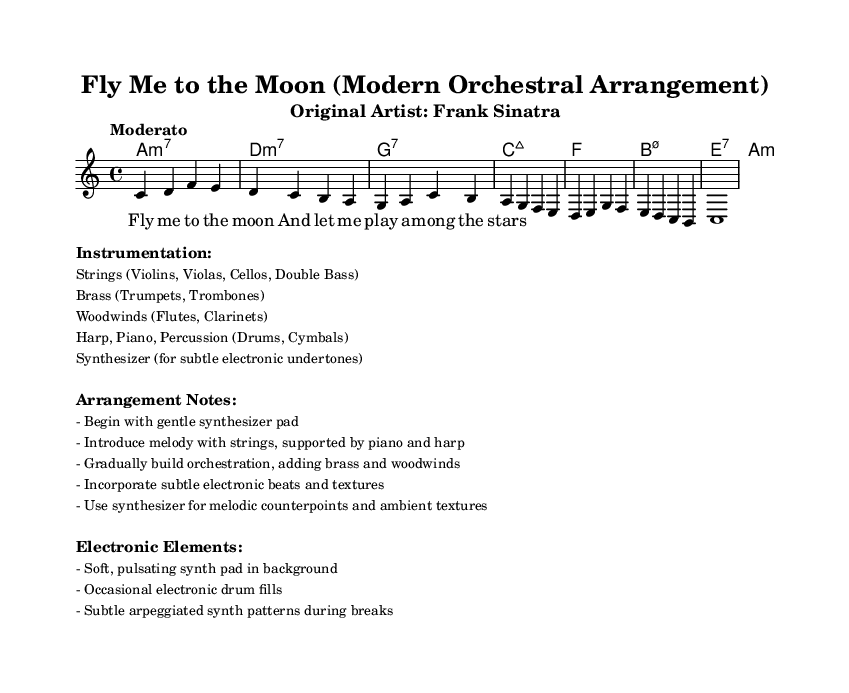What is the key signature of this music? The key signature is C major, which has no sharps or flats.
Answer: C major What is the time signature of this piece? The time signature is indicated at the beginning of the score, showing there are four beats per measure.
Answer: 4/4 What is the tempo marking for the arrangement? The tempo marking indicates it should be played at a moderate pace, as specified in the score at the beginning.
Answer: Moderato How many instruments are listed in the instrumentation? The instrumentation section explicitly lists six categories of instruments involved in the arrangement.
Answer: Six What is the first electronic element mentioned in the arrangement notes? The arrangement notes specify that the piece should begin with a gentle synthesizer pad, highlighting the first electronic element used.
Answer: Synthesizer pad What type of chord progression is used in this arrangement? The chord progression consists of various seventh chords that provide a lush harmonic foundation throughout the piece.
Answer: Seventh chords What is the melodic instrument highlighted in this arrangement? The arrangement notes indicate that the melody is introduced by strings, making them the primary melodic instrument in this version of the piece.
Answer: Strings 